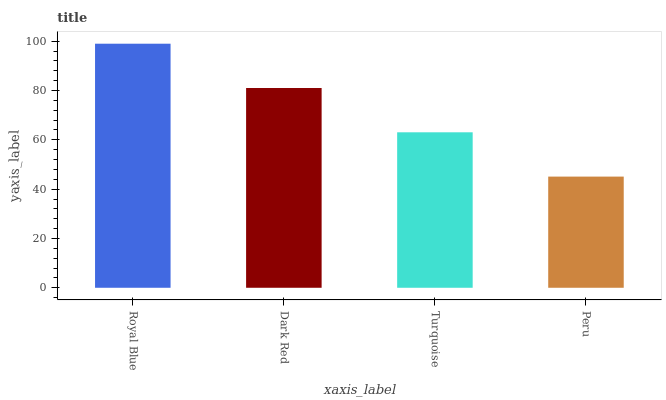Is Dark Red the minimum?
Answer yes or no. No. Is Dark Red the maximum?
Answer yes or no. No. Is Royal Blue greater than Dark Red?
Answer yes or no. Yes. Is Dark Red less than Royal Blue?
Answer yes or no. Yes. Is Dark Red greater than Royal Blue?
Answer yes or no. No. Is Royal Blue less than Dark Red?
Answer yes or no. No. Is Dark Red the high median?
Answer yes or no. Yes. Is Turquoise the low median?
Answer yes or no. Yes. Is Peru the high median?
Answer yes or no. No. Is Royal Blue the low median?
Answer yes or no. No. 